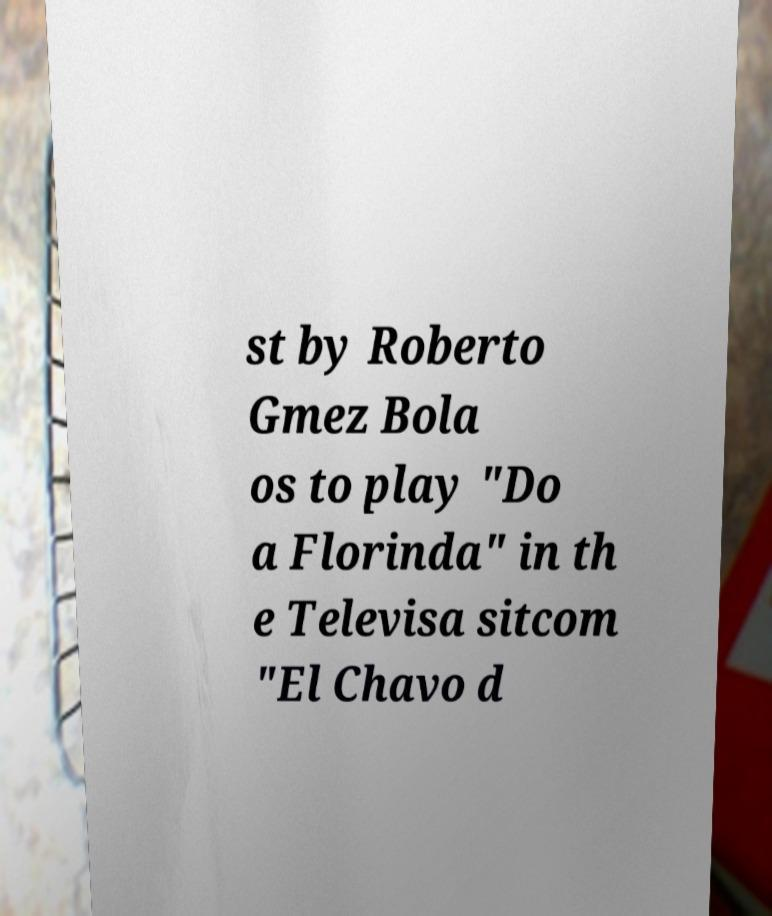Could you assist in decoding the text presented in this image and type it out clearly? st by Roberto Gmez Bola os to play "Do a Florinda" in th e Televisa sitcom "El Chavo d 